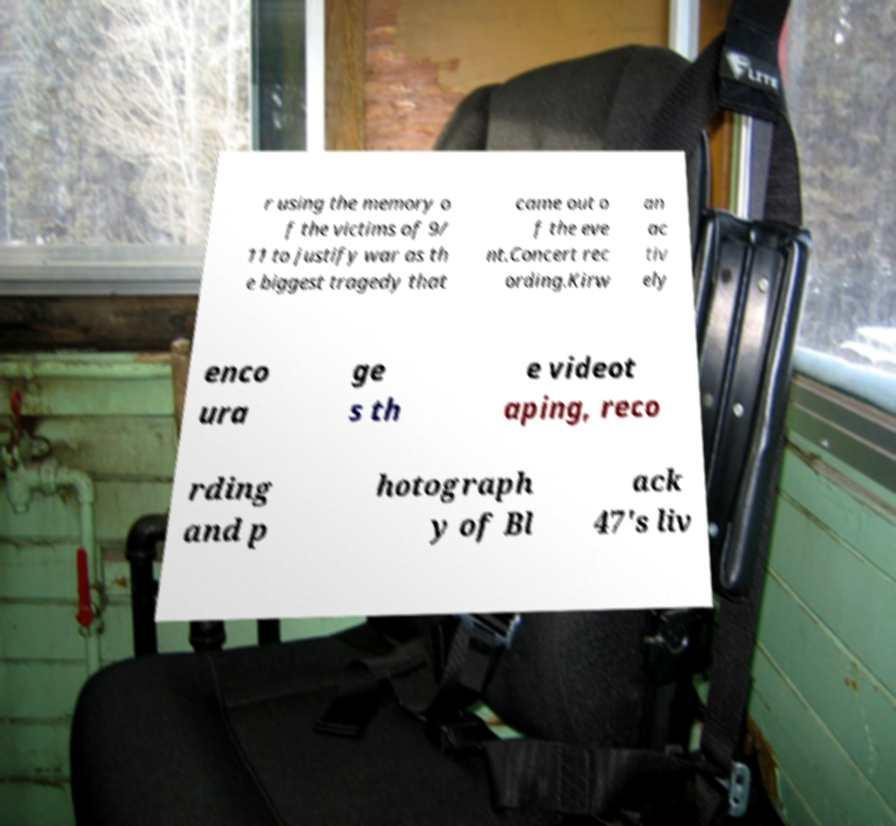For documentation purposes, I need the text within this image transcribed. Could you provide that? r using the memory o f the victims of 9/ 11 to justify war as th e biggest tragedy that came out o f the eve nt.Concert rec ording.Kirw an ac tiv ely enco ura ge s th e videot aping, reco rding and p hotograph y of Bl ack 47's liv 